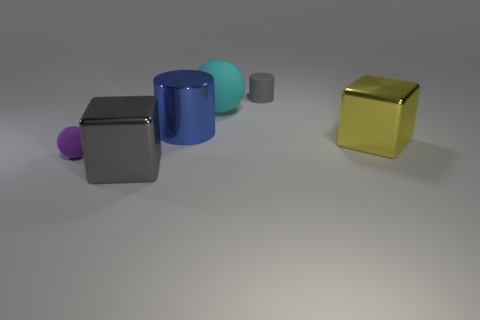Subtract 1 cylinders. How many cylinders are left? 1 Add 3 tiny cyan metal blocks. How many objects exist? 9 Subtract all purple balls. How many balls are left? 1 Subtract all spheres. How many objects are left? 4 Add 4 gray objects. How many gray objects are left? 6 Add 4 purple rubber cylinders. How many purple rubber cylinders exist? 4 Subtract 0 yellow cylinders. How many objects are left? 6 Subtract all purple blocks. Subtract all yellow cylinders. How many blocks are left? 2 Subtract all gray metal things. Subtract all large metallic cubes. How many objects are left? 3 